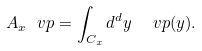<formula> <loc_0><loc_0><loc_500><loc_500>A _ { x } \ v p = \int _ { C _ { x } } d ^ { d } y \ \ v p ( y ) .</formula> 